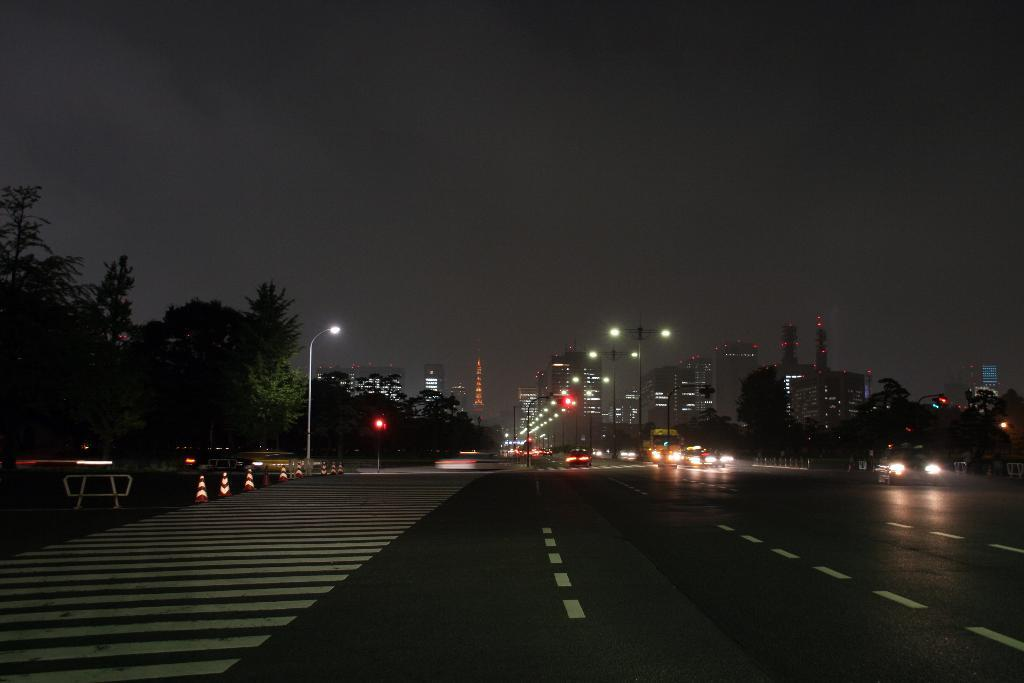What can be seen on the road in the image? There are vehicles on the road in the image. What is visible in the background of the image? The sky, trees, poles, lights, a traffic police officer, sign boards, grass, and traffic lights are visible in the background of the image. Reasoning: Let' Let's think step by step in order to produce the conversation. We start by identifying the main subject in the image, which is the vehicles on the road. Then, we expand the conversation to include the various elements visible in the background of the image, as provided by the facts. Each question is designed to elicit a specific detail about the image that is known from the provided facts. Absurd Question/Answer: What is the cause of the anger in the image? There is no indication of anger in the image; it depicts vehicles on the road and various elements in the background. What is the texture of the traffic police officer's uniform in the image? There is no information about the texture of the traffic police officer's uniform in the image, as it is not mentioned in the provided facts. 